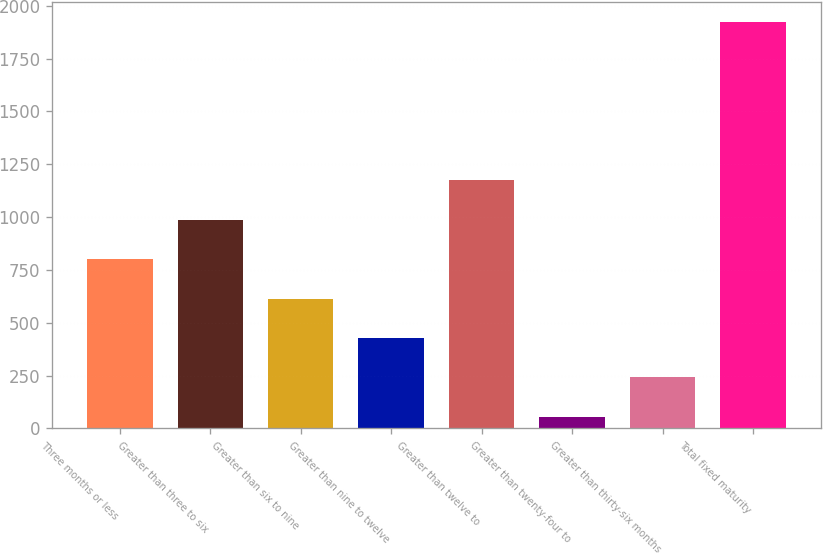<chart> <loc_0><loc_0><loc_500><loc_500><bar_chart><fcel>Three months or less<fcel>Greater than three to six<fcel>Greater than six to nine<fcel>Greater than nine to twelve<fcel>Greater than twelve to<fcel>Greater than twenty-four to<fcel>Greater than thirty-six months<fcel>Total fixed maturity<nl><fcel>801.58<fcel>988.35<fcel>614.81<fcel>428.04<fcel>1175.12<fcel>54.5<fcel>241.27<fcel>1922.2<nl></chart> 